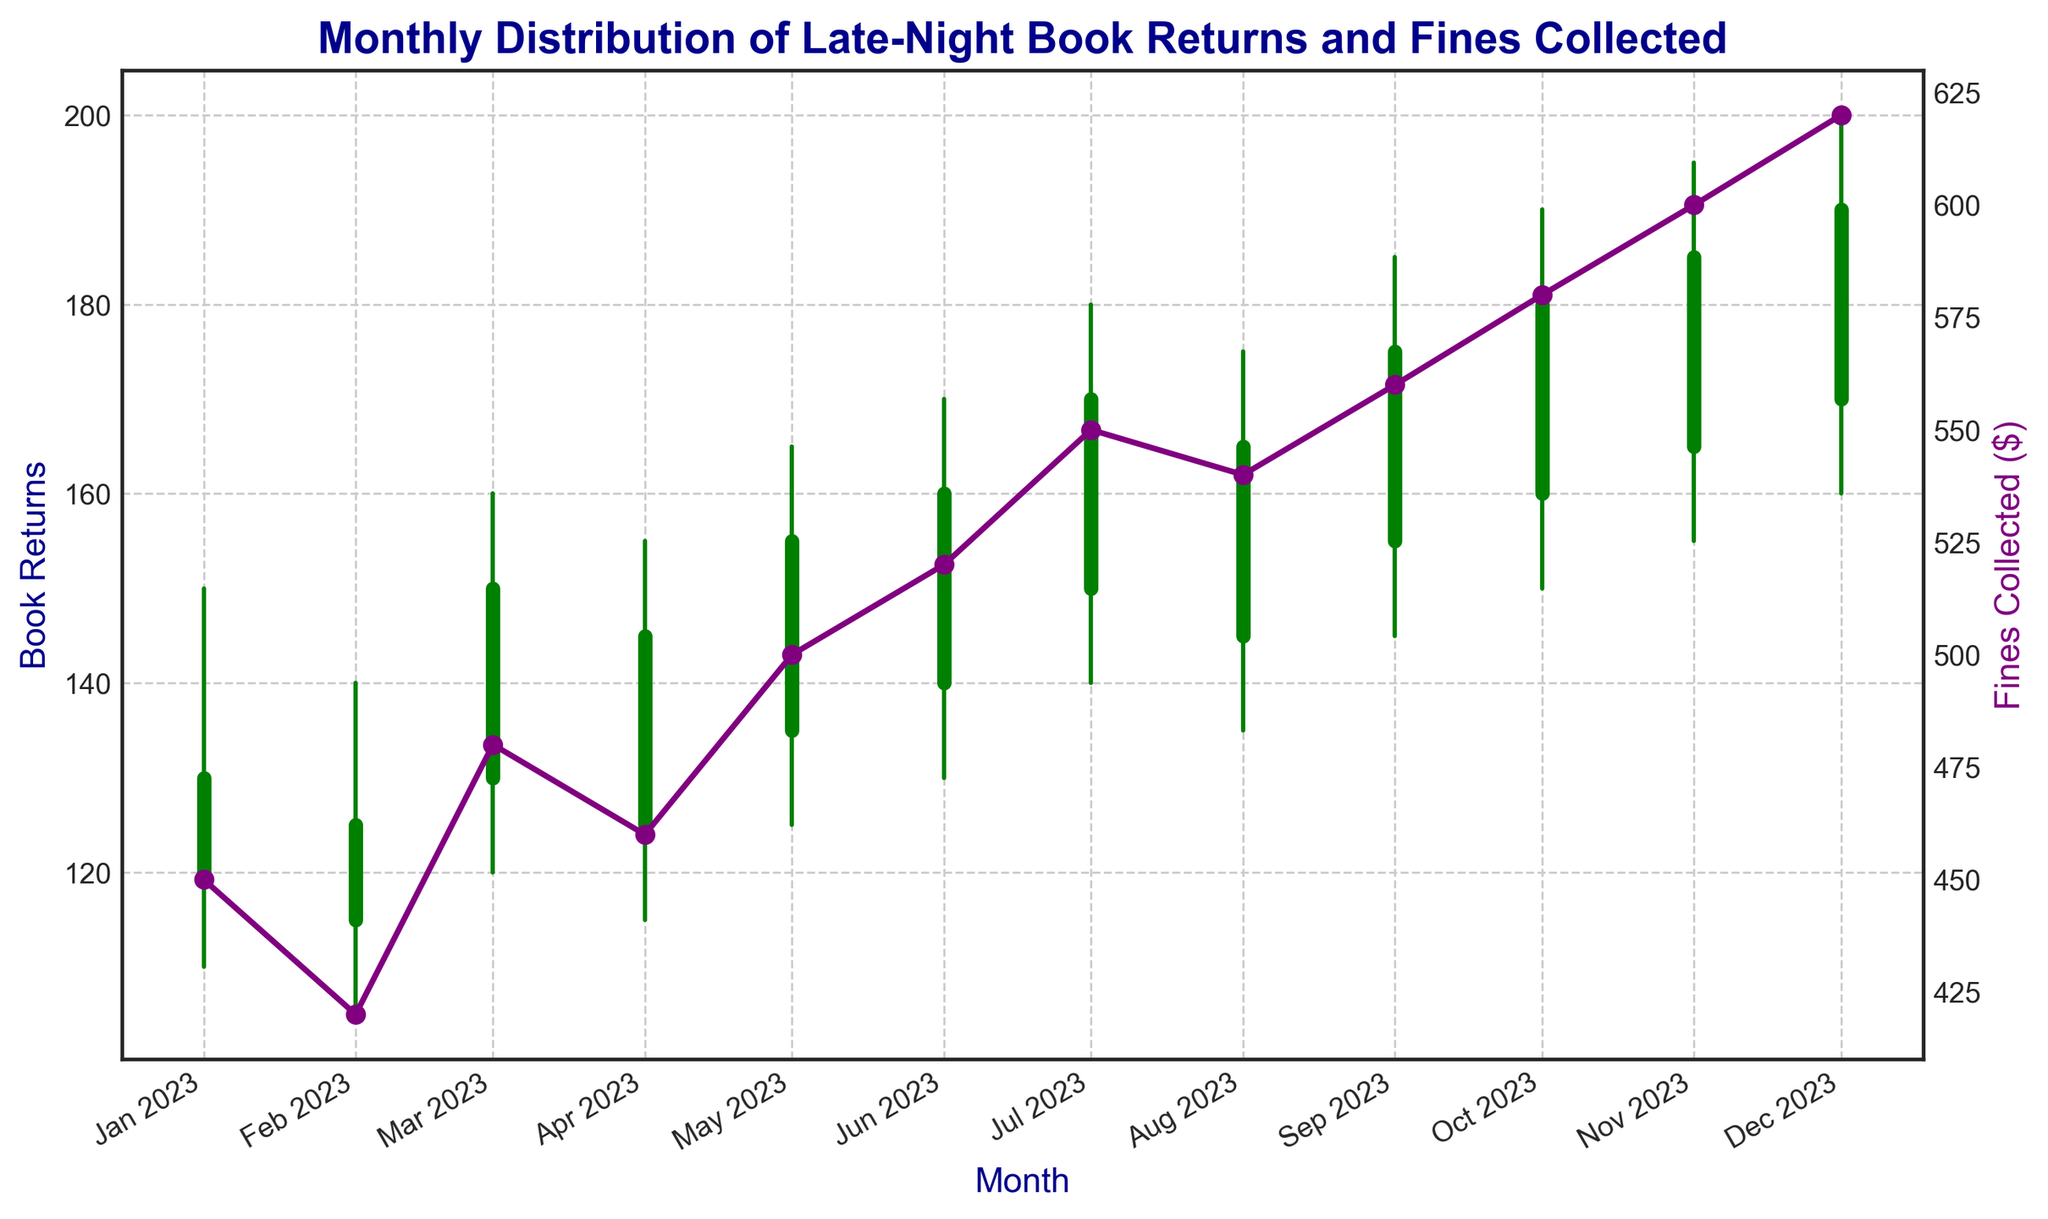What trend do you notice in the monthly fines collected from January to December? The amount of fines collected shows an increasing trend from January ($450) to December ($620). Each month sees a progressively higher amount of fines collected.
Answer: Increasing In which month was the highest high value recorded for book returns? The highest high value for book returns was recorded in December, with a high value of 200.
Answer: December Which month had the smallest difference between the open and close values for book returns? February had the smallest difference between the open and close values, with values of 115 (open) and 125 (close), making a difference of 10.
Answer: February How many months had the close value higher than the open value? By examining each month, you can see that nine months had a close value higher than their open values: January, March, April, May, June, July, August, September, and October.
Answer: Nine months What's the total amount of fines collected in the first half of the year (January to June)? Sum the fines collected from January to June: 450 (Jan) + 420 (Feb) + 480 (Mar) + 460 (Apr) + 500 (May) + 520 (Jun) = 2830.
Answer: 2830 What do the green and red bars represent in the candlestick chart? In the candlestick chart, the green bars indicate that the closing value for that month was higher than the opening value, whereas the red bars indicate that the closing value was lower than the opening value.
Answer: Green: Higher Close, Red: Lower Close Which month experienced the highest decrease in book returns from its high to its low value? February experienced the highest decrease in book returns, with a high value of 140 and a low value of 105, making the difference 35.
Answer: February Between which two adjacent months was the most significant jump in fines collected? By examining the fines collected, the most significant jump between two adjacent months is between November ($600) and December ($620), a difference of $20.
Answer: November to December What is the average fines collected per month over the entire year? Sum the total fines collected for the year and divide by 12 months: (450 + 420 + 480 + 460 + 500 + 520 + 550 + 540 + 560 + 580 + 600 + 620) / 12 = 5640 / 12 = 470.
Answer: 470 What is the lowest closing value recorded and in which month? The lowest closing value for book returns is 125, which was recorded in February.
Answer: 125 in February 